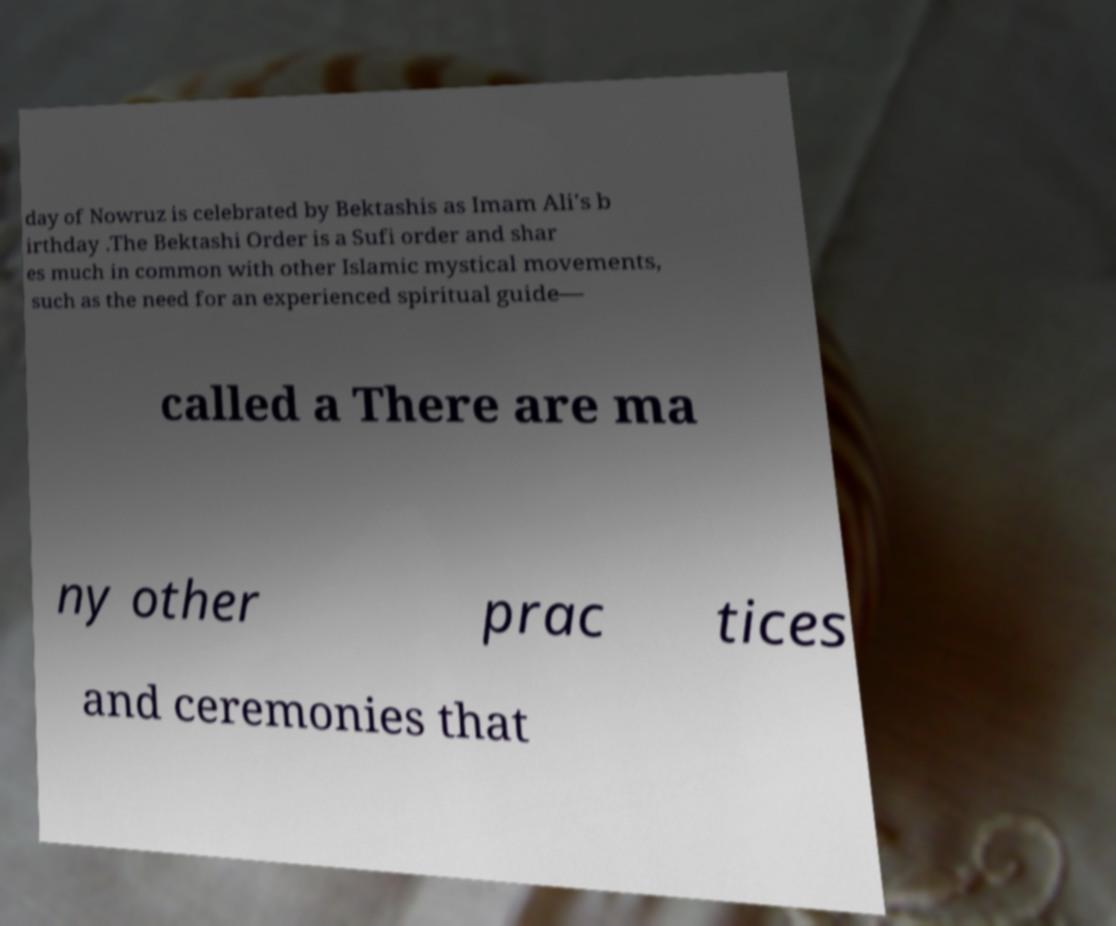For documentation purposes, I need the text within this image transcribed. Could you provide that? day of Nowruz is celebrated by Bektashis as Imam Ali's b irthday .The Bektashi Order is a Sufi order and shar es much in common with other Islamic mystical movements, such as the need for an experienced spiritual guide— called a There are ma ny other prac tices and ceremonies that 